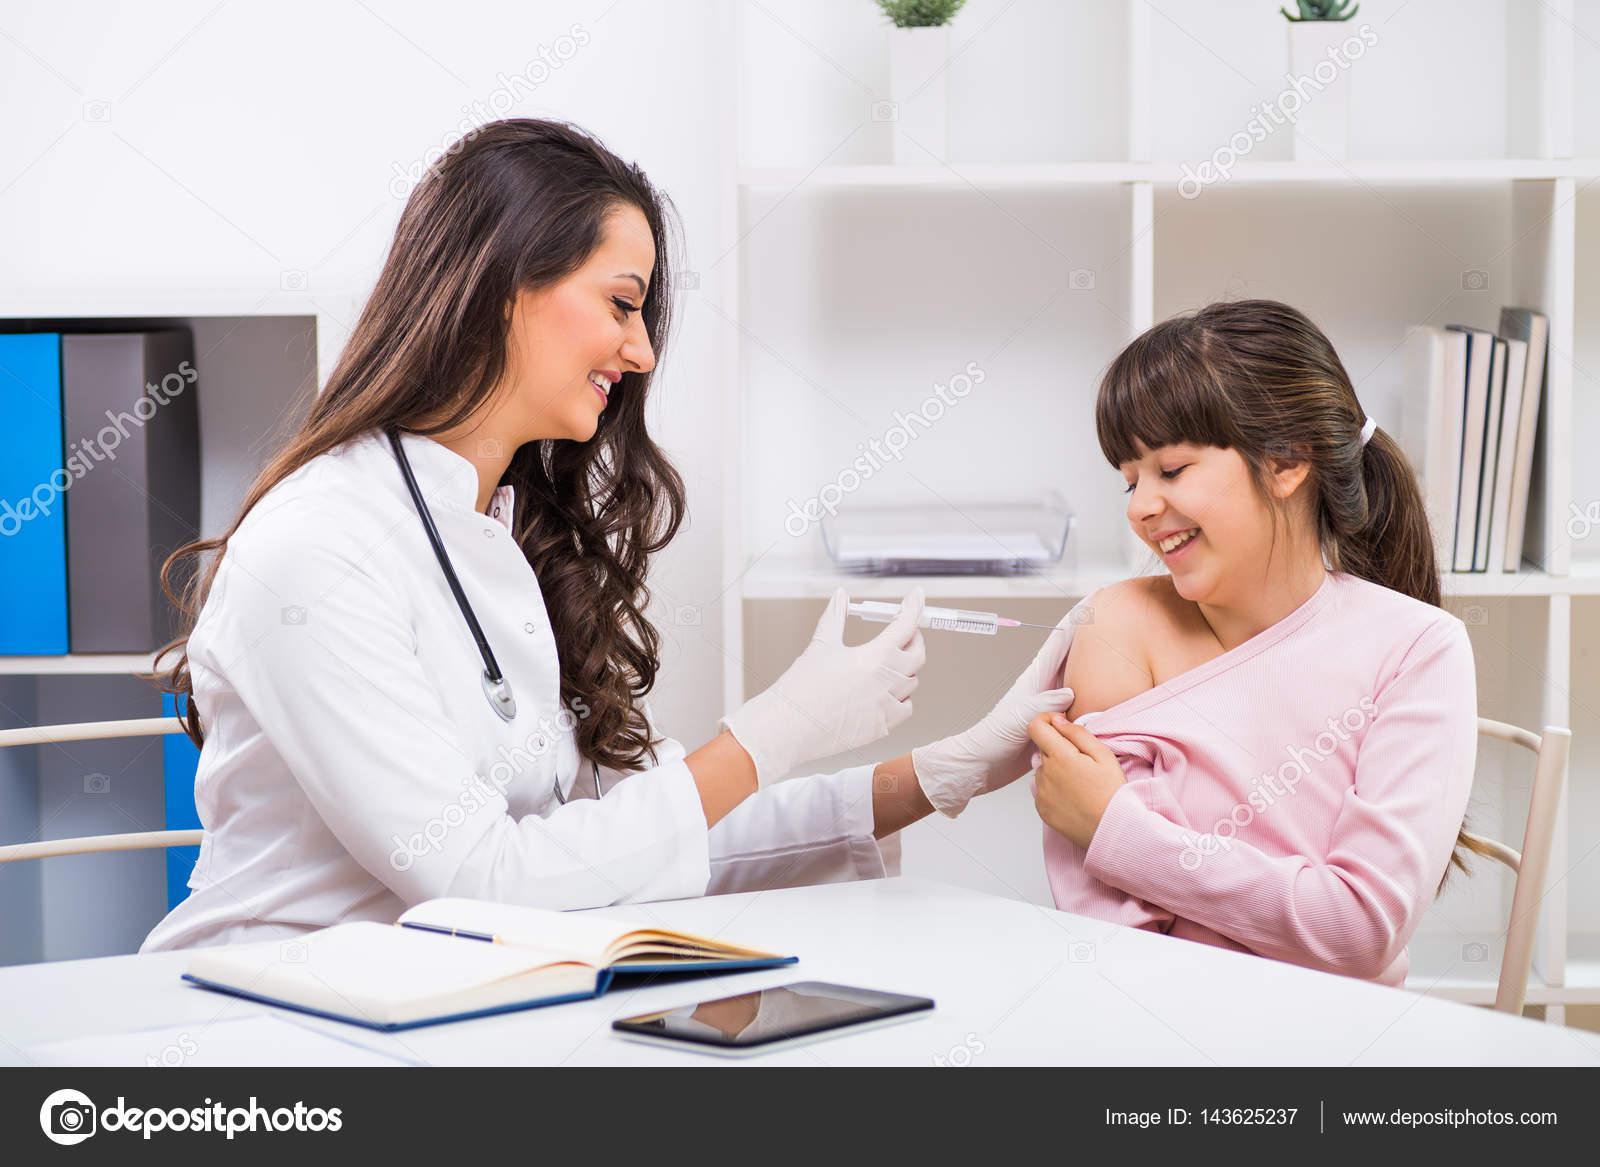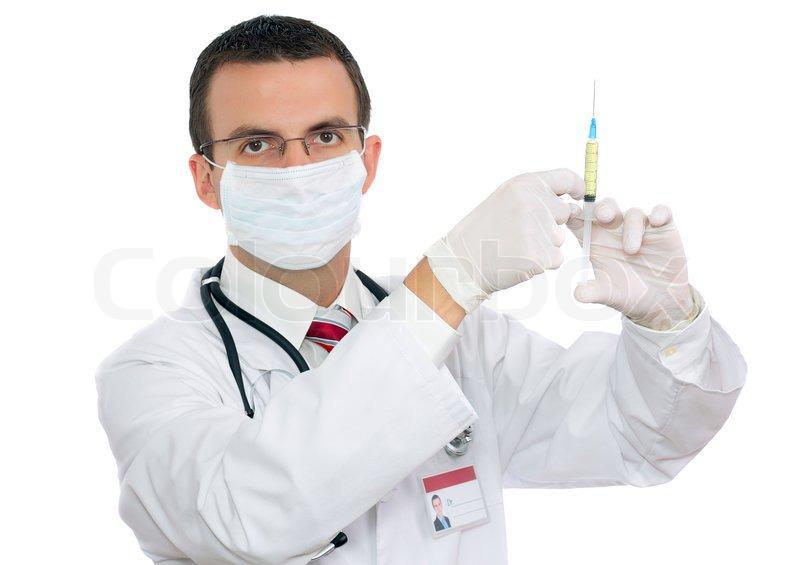The first image is the image on the left, the second image is the image on the right. Analyze the images presented: Is the assertion "The right image shows a woman in a white lab coat holding up a hypodermic needle and looking at it." valid? Answer yes or no. No. The first image is the image on the left, the second image is the image on the right. Assess this claim about the two images: "The left and right image contains two doctors and one patient.". Correct or not? Answer yes or no. Yes. 